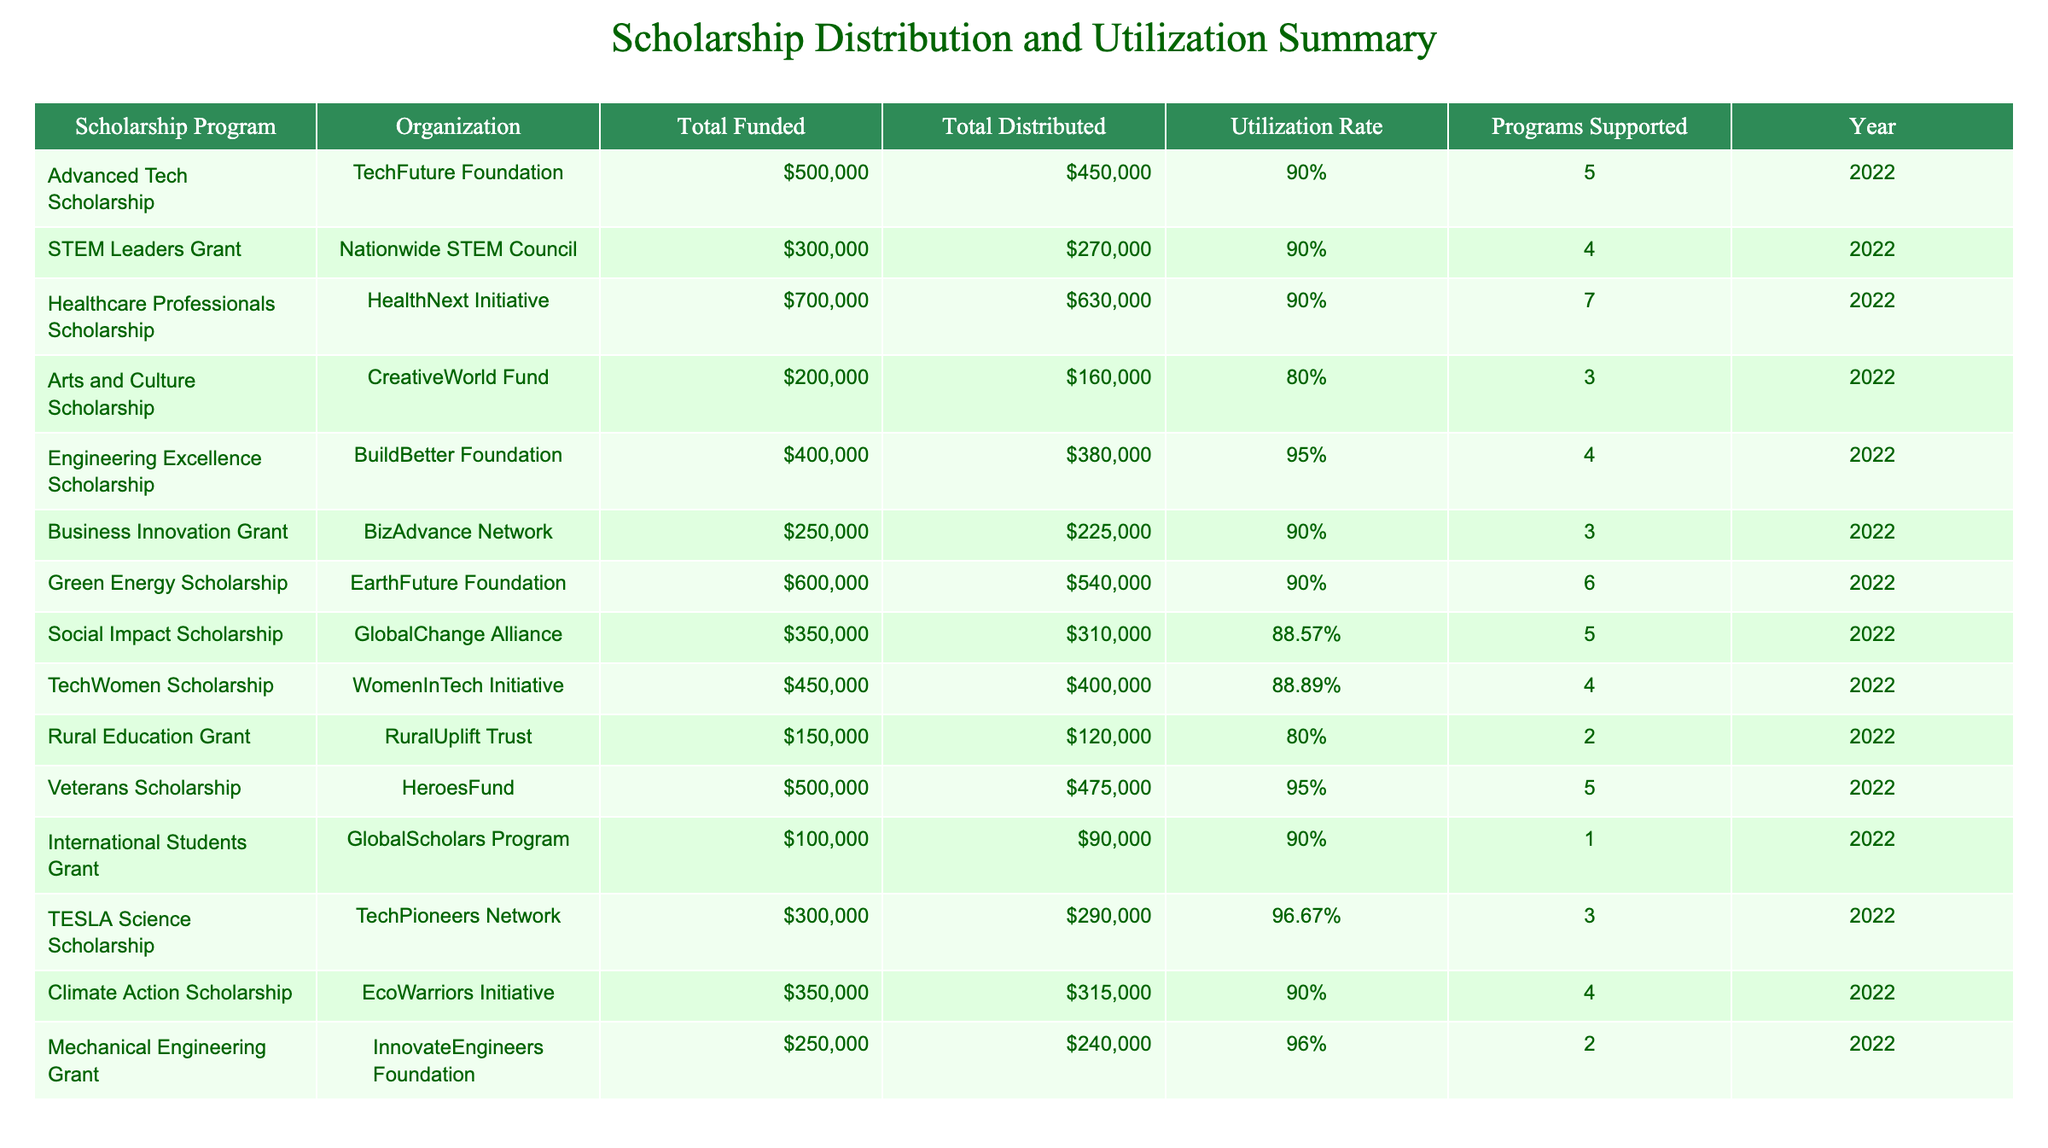What is the total amount funded for the Healthcare Professionals Scholarship? The table shows that the "Total Funded" for the Healthcare Professionals Scholarship is listed as $700,000.
Answer: $700,000 What is the utilization rate of the TechWomen Scholarship? The utilization rate for the TechWomen Scholarship, as indicated in the table, is 88.89%.
Answer: 88.89% Which scholarship program had the highest total distributed amount? By examining the "Total Distributed" column, the Healthcare Professionals Scholarship has the highest amount, totaling $630,000.
Answer: Healthcare Professionals Scholarship What is the average total distributed amount across all scholarship programs? To find the average, sum the total distributed amounts: 450000 + 270000 + 630000 + 160000 + 380000 + 225000 + 540000 + 310000 + 400000 + 120000 + 475000 + 90000 + 290000 + 315000 + 240000 = 3,510,000. Dividing by the number of programs (15), the average is 3,510,000 / 15 = 234,000.
Answer: $234,000 Is there a scholarship program that reports a utilization rate of exactly 90%? Yes, by checking the "Utilization Rate" column, there are multiple programs with a utilization rate of exactly 90%, such as the Advanced Tech Scholarship and the STEM Leaders Grant.
Answer: Yes Which organization supports the Rural Education Grant? The table lists the organization supporting the Rural Education Grant as the "RuralUplift Trust."
Answer: RuralUplift Trust How many programs does the Green Energy Scholarship support? The number of programs supported by the Green Energy Scholarship is 6, as stated in the "Programs Supported" column.
Answer: 6 What is the difference between total distributed amounts of the Arts and Culture Scholarship and the Engineering Excellence Scholarship? The total distributed for the Arts and Culture Scholarship is $160,000 and for the Engineering Excellence Scholarship is $380,000. The difference is 380000 - 160000 = 220000.
Answer: $220,000 Which scholarship program has the lowest utilization rate? Upon reviewing the utilization rates, the Rural Education Grant and the Arts and Culture Scholarship both have the lowest at 80%.
Answer: Rural Education Grant and Arts and Culture Scholarship 